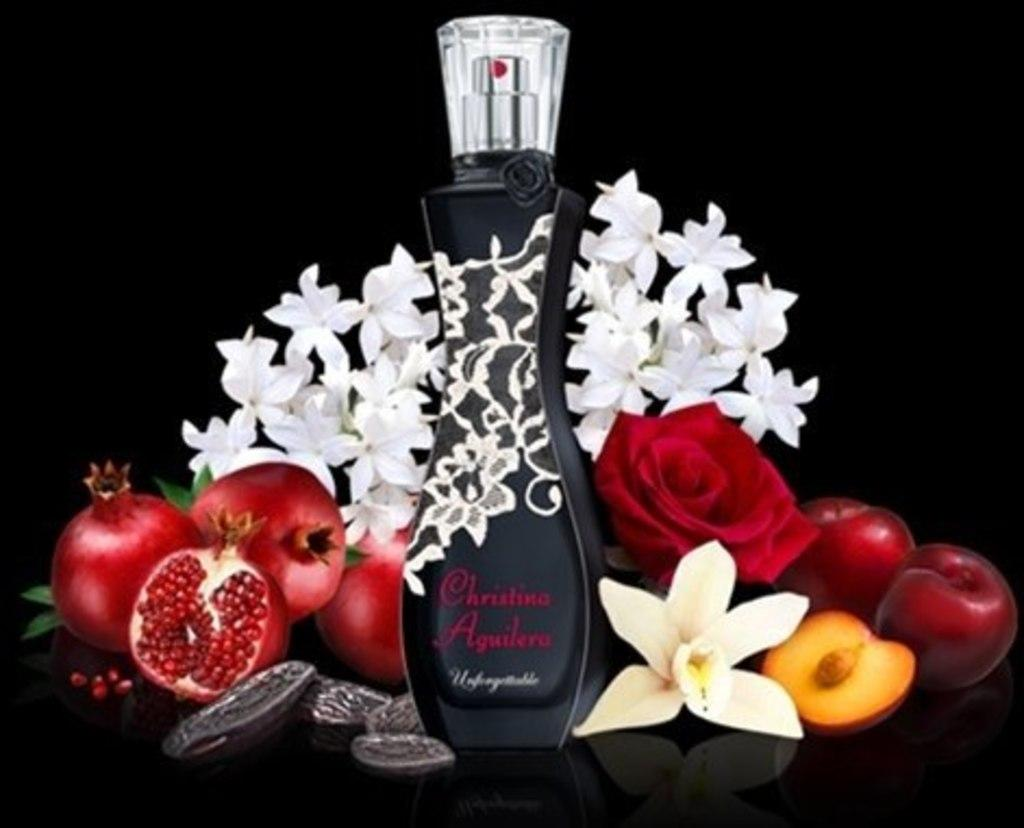<image>
Give a short and clear explanation of the subsequent image. A bottle of Christina Aguilera perfume surrounded by fruits and flowers. 